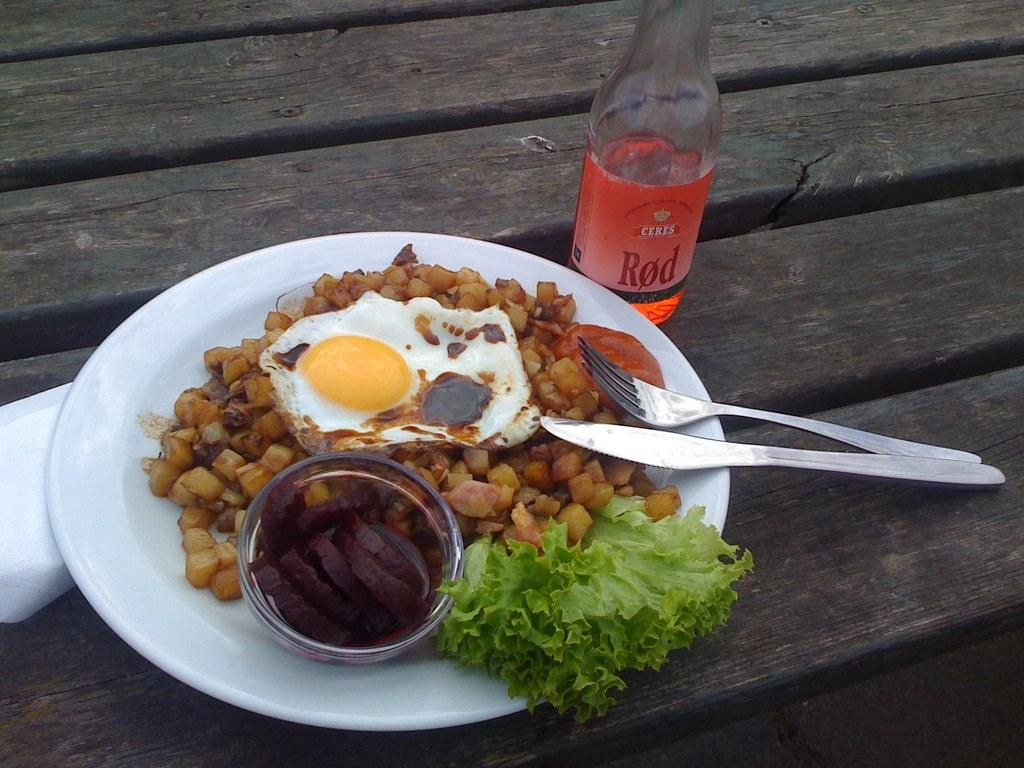What type of food can be seen in the image? There is a food with omelette in the image. What utensils are available for eating the food? A fork and knife are present in the image. On what is the food placed? The food is placed on a white plate. Where is the white plate located? The white plate is on a wooden bench. What beverage accompanies the food? There is a red wine bottle in the image. What item might be used for cleaning or wiping in the image? Tissue is present in the image. Can you see any wings on the omelette in the image? There are no wings visible on the omelette in the image. 